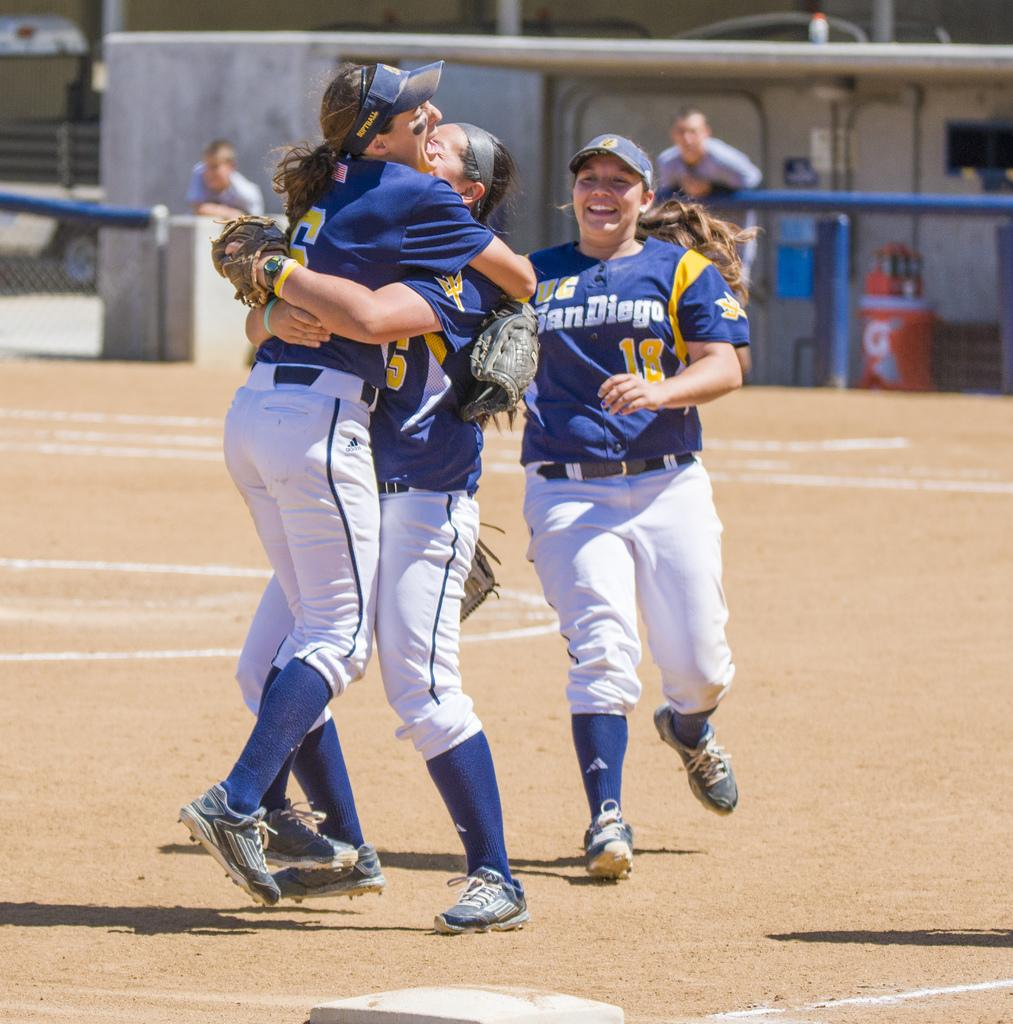<image>
Summarize the visual content of the image. Two members of the UC San Diego softball team hugging with another girl joining them.. 